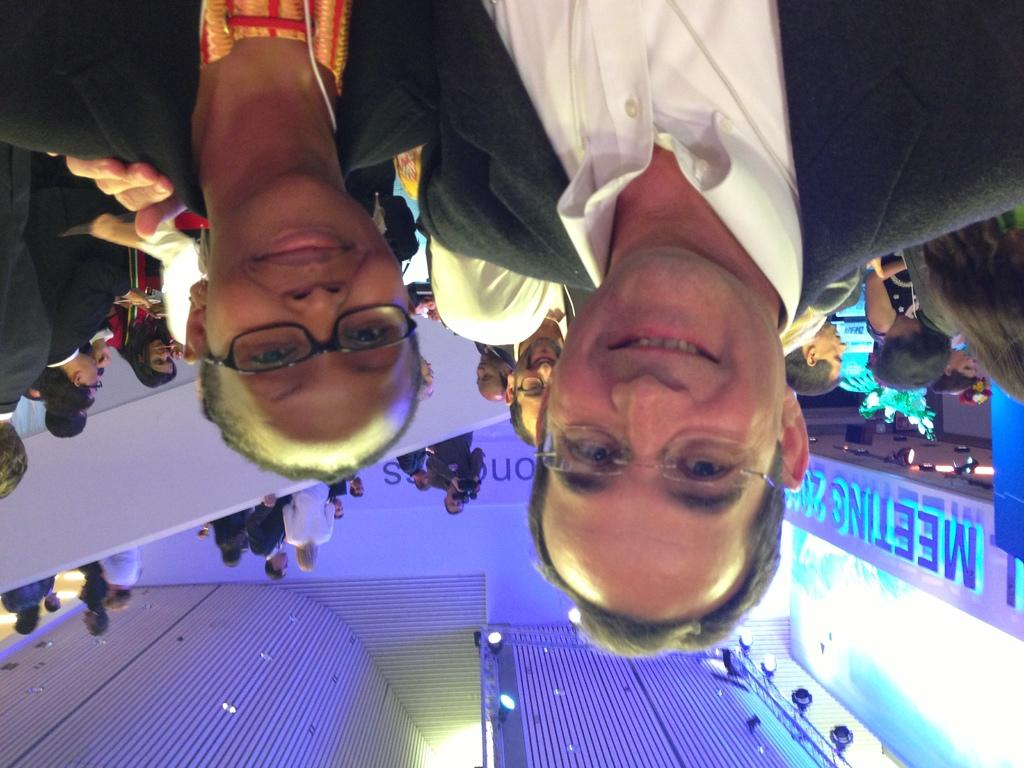How many people are wearing spectacles in the image? There are two people in the image wearing spectacles. What expression do the two people have? The two people are smiling. What can be seen in the background of the image? There is a group of people, lights, and some objects visible in the background of the image. What type of sound can be heard coming from the coach in the image? There is no coach present in the image, so it's not possible to determine what, if any, sound might be heard. How many chairs are visible in the image? There is no mention of chairs in the provided facts, so it's not possible to determine how many chairs might be visible in the image. 